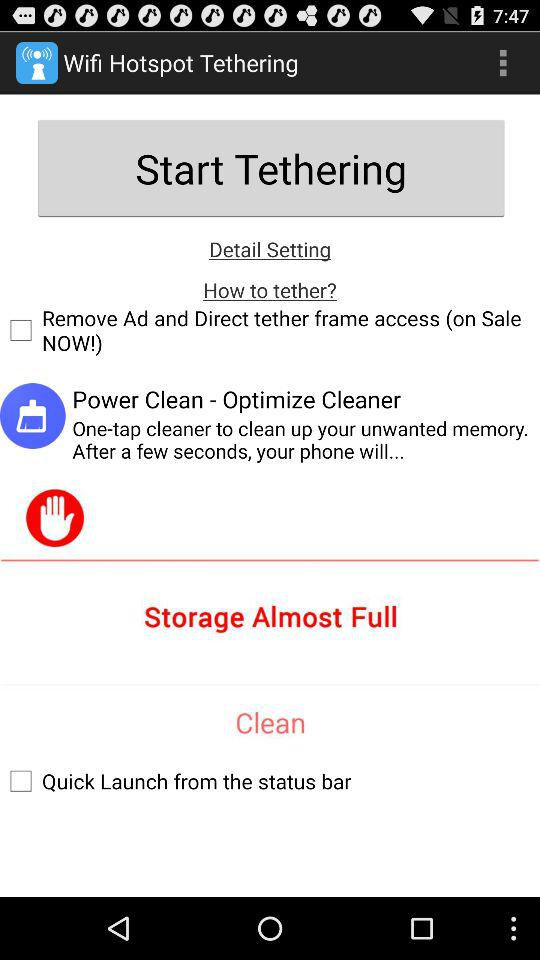What is the current status of the "Quick Launch from the status bar"? The current status is "off". 